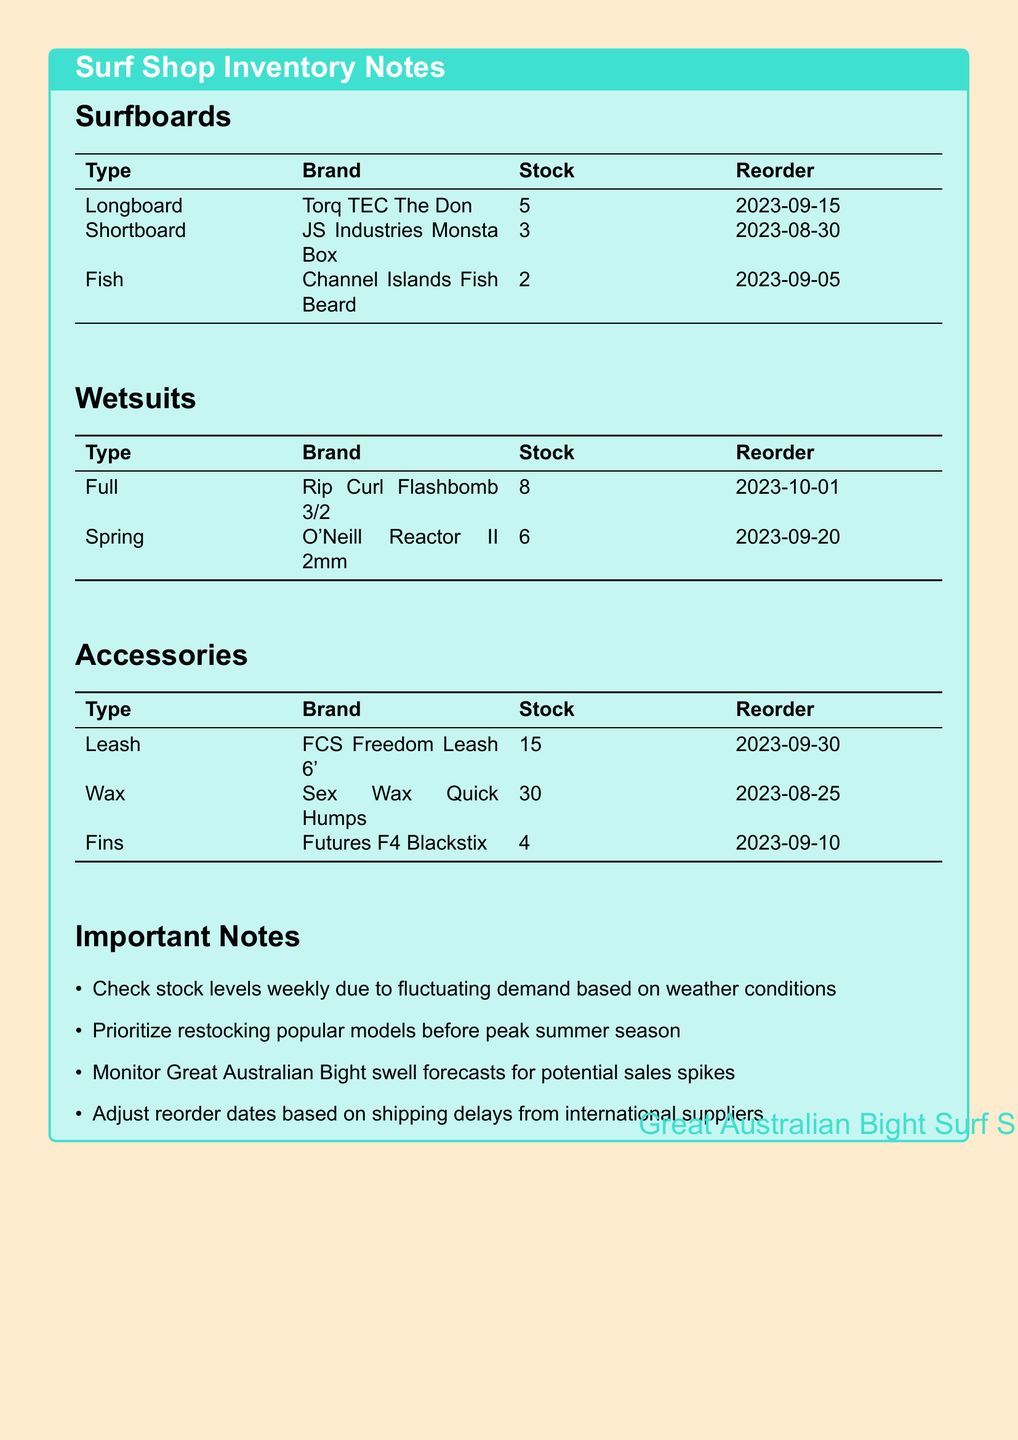What type of surfboard has 5 in stock? The document states that the Torq TEC The Don, which is a Longboard, has 5 in stock.
Answer: Longboard When is the reorder date for the O'Neill Reactor II 2mm wetsuit? The document lists the reorder date for the O'Neill Reactor II 2mm wetsuit as September 20, 2023.
Answer: 2023-09-20 How many units of Futures F4 Blackstix fins are in stock? According to the document, there are 4 units of Futures F4 Blackstix fins currently in stock.
Answer: 4 What model of wetsuit has the highest stock level? The document indicates that the Rip Curl Flashbomb 3/2 has the highest stock level with 8 units available.
Answer: Flashbomb 3/2 Which accessory has the most stock? The document shows that the Sex Wax Quick Humps has the most stock with 30 units available.
Answer: 30 What should be monitored for potential sales spikes? The document notes that the Great Australian Bight swell forecasts should be monitored for potential sales spikes.
Answer: Great Australian Bight swell forecasts How often should stock levels be checked? The document advises checking stock levels weekly due to fluctuating demand.
Answer: Weekly What is the reorder date for the Leash accessory? The document states that the reorder date for the FCS Freedom Leash 6' is September 30, 2023.
Answer: 2023-09-30 Why should reorder dates be adjusted? The document mentions that reorder dates should be adjusted based on shipping delays from international suppliers.
Answer: Shipping delays 